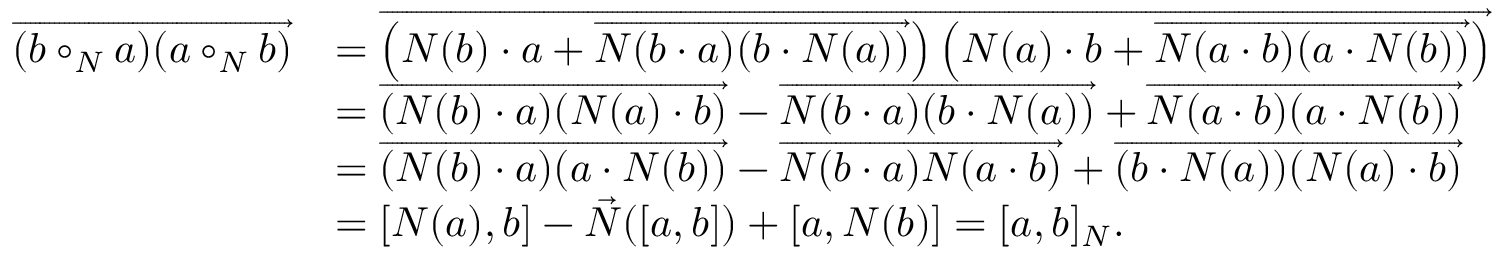<formula> <loc_0><loc_0><loc_500><loc_500>\begin{array} { r l } { \overrightarrow { ( b \circ _ { N } a ) ( a \circ _ { N } b ) } } & { = \overrightarrow { \left ( N ( b ) \cdot a + \overrightarrow { N ( b \cdot a ) ( b \cdot N ( a ) ) } \right ) \left ( N ( a ) \cdot b + \overrightarrow { N ( a \cdot b ) ( a \cdot N ( b ) ) } \right ) } } \\ & { = \overrightarrow { ( N ( b ) \cdot a ) ( N ( a ) \cdot b ) } - \overrightarrow { N ( b \cdot a ) ( b \cdot N ( a ) ) } + \overrightarrow { N ( a \cdot b ) ( a \cdot N ( b ) ) } } \\ & { = \overrightarrow { ( N ( b ) \cdot a ) ( a \cdot N ( b ) ) } - \overrightarrow { N ( b \cdot a ) N ( a \cdot b ) } + \overrightarrow { ( b \cdot N ( a ) ) ( N ( a ) \cdot b ) } } \\ & { = [ N ( a ) , b ] - \vec { N } ( [ a , b ] ) + [ a , N ( b ) ] = [ a , b ] _ { N } . } \end{array}</formula> 